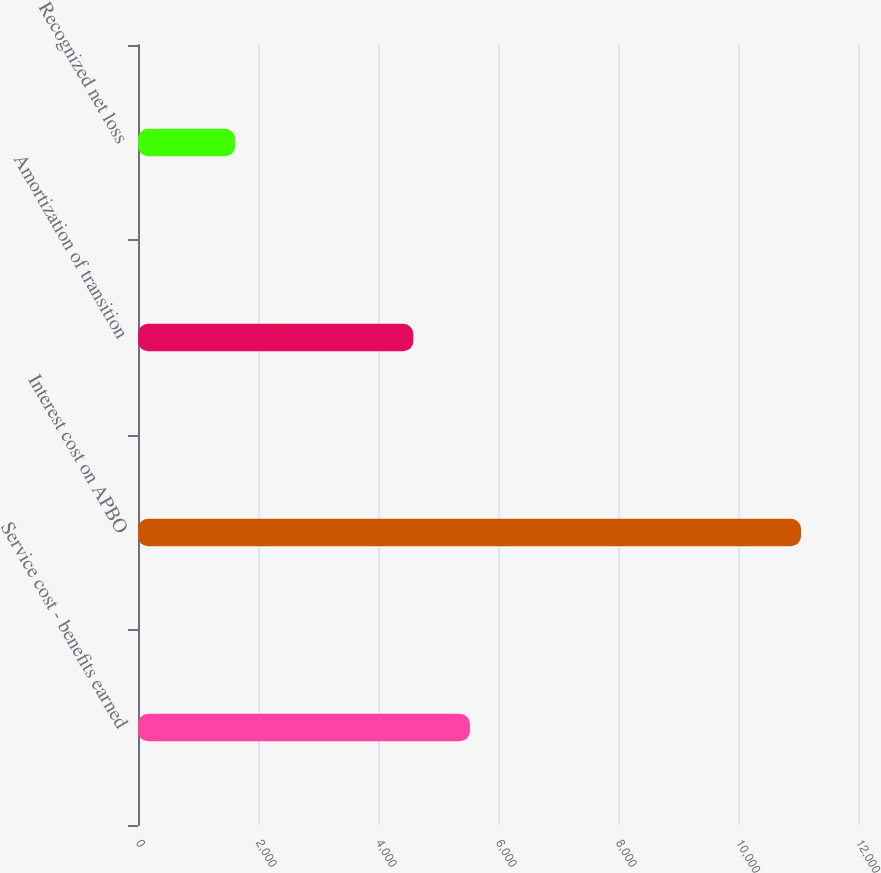Convert chart. <chart><loc_0><loc_0><loc_500><loc_500><bar_chart><fcel>Service cost - benefits earned<fcel>Interest cost on APBO<fcel>Amortization of transition<fcel>Recognized net loss<nl><fcel>5532<fcel>11050<fcel>4589<fcel>1620<nl></chart> 